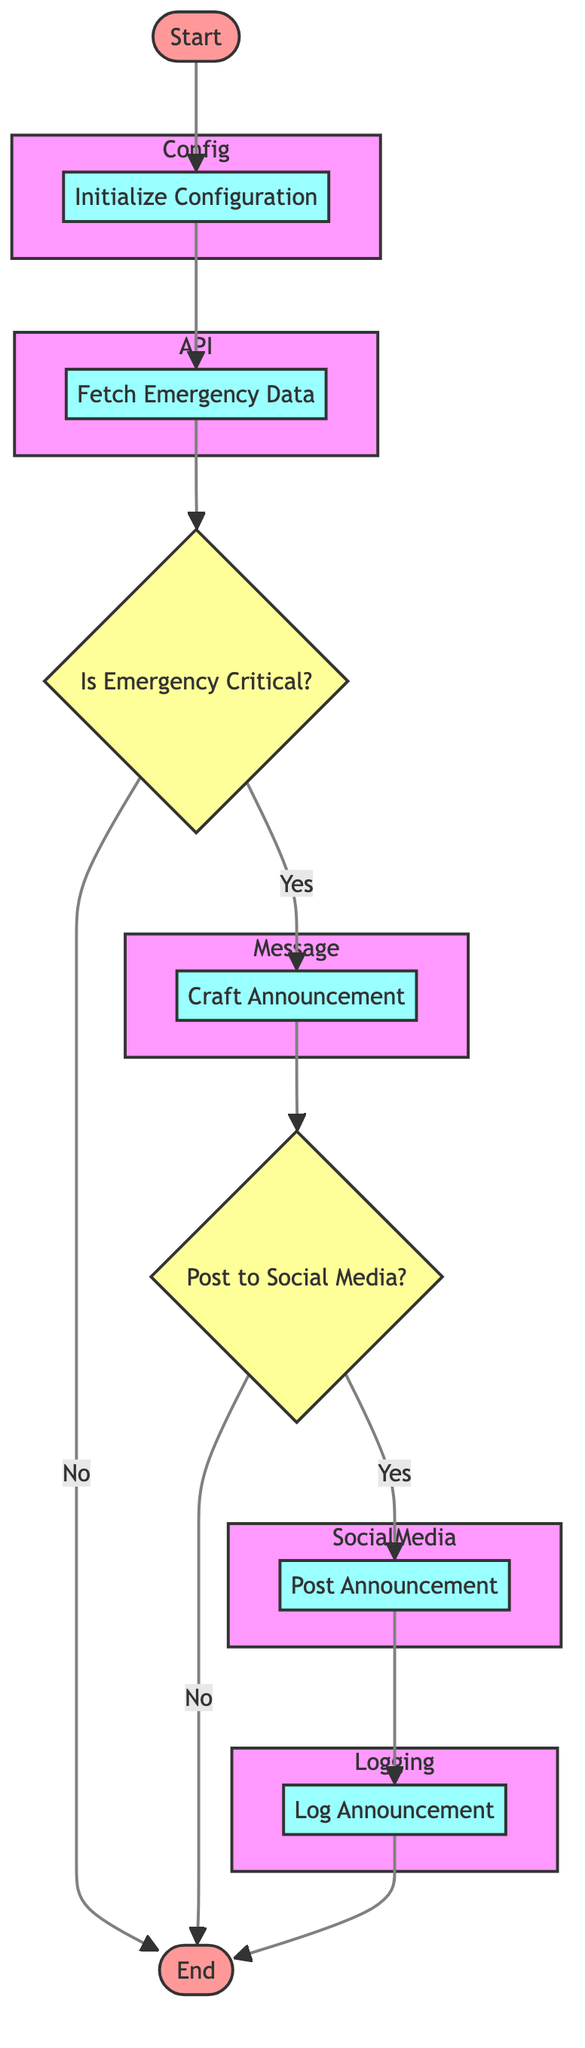What is the first process in the flowchart? The first process listed in the flowchart is "Initialize Configuration." This is the first step after the starting point, as indicated by the flow from "Start" to "Initialize Configuration."
Answer: Initialize Configuration How many decision nodes are present in the diagram? The diagram contains two decision nodes: "Is Emergency Critical?" and "Post to Social Media?". These can be counted by identifying nodes with diamond shapes.
Answer: 2 What happens if the emergency is classified as critical? If classified as critical, the flowchart indicates that the process continues to the "Craft Announcement" step, as it follows the "Yes" path from the "Is Emergency Critical?" decision node.
Answer: Craft Announcement What is logged after posting an announcement? After posting the announcement, the flowchart specifies that "Log Announcement" will be executed. This is part of the flow after the "Post Announcement" process.
Answer: Log Announcement Which process includes API interactions? The process that includes API interactions is "Post Announcement." This step indicates that the announcement will be published using the social media APIs, distinguishing it from other processes that do not involve APIs.
Answer: Post Announcement What occurs if "Post to Social Media?" is answered with "No"? If "Post to Social Media?" is answered with "No," the flowchart indicates that the flow will end after skipping to "End" without executing the posting process.
Answer: End Which two platforms are mentioned for posting announcements? The two platforms mentioned for posting announcements are Twitter and Facebook, as specified in the "Post Announcement" process section where API endpoints for both platforms are provided.
Answer: Twitter and Facebook What is the purpose of initializing configuration? The purpose of initializing configuration is to load API keys, message templates, and other settings from a configuration file, as described in the details of the "Initialize Configuration" process.
Answer: Load API keys and templates 